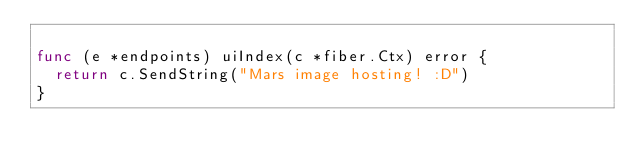<code> <loc_0><loc_0><loc_500><loc_500><_Go_>
func (e *endpoints) uiIndex(c *fiber.Ctx) error {
	return c.SendString("Mars image hosting! :D")
}
</code> 